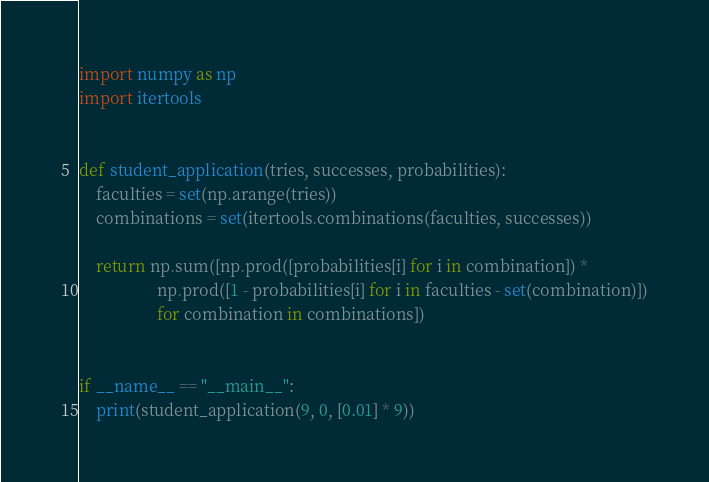Convert code to text. <code><loc_0><loc_0><loc_500><loc_500><_Python_>import numpy as np
import itertools


def student_application(tries, successes, probabilities):
    faculties = set(np.arange(tries))
    combinations = set(itertools.combinations(faculties, successes))

    return np.sum([np.prod([probabilities[i] for i in combination]) *
                   np.prod([1 - probabilities[i] for i in faculties - set(combination)])
                   for combination in combinations])


if __name__ == "__main__":
    print(student_application(9, 0, [0.01] * 9))
</code> 